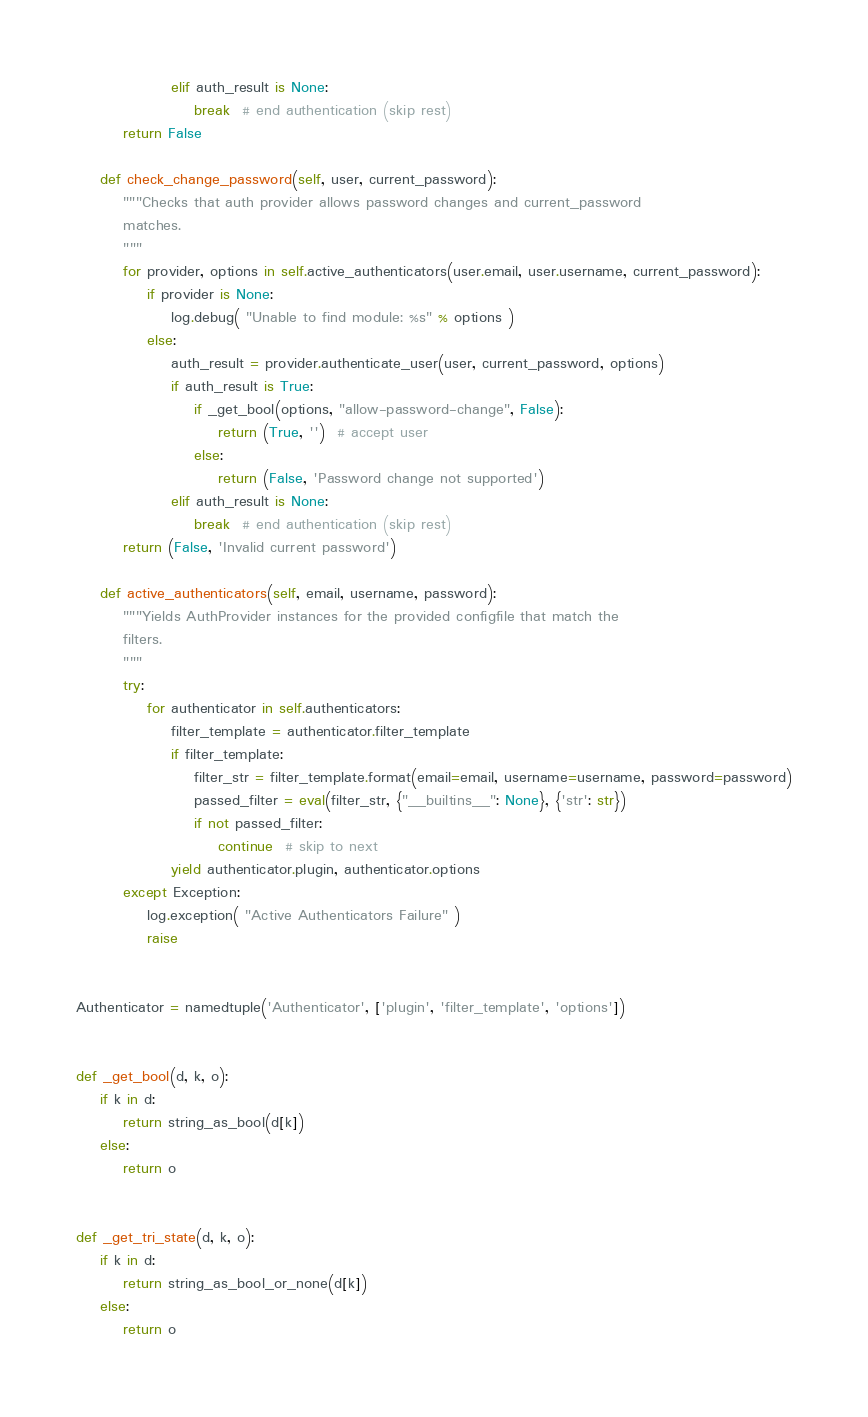Convert code to text. <code><loc_0><loc_0><loc_500><loc_500><_Python_>                elif auth_result is None:
                    break  # end authentication (skip rest)
        return False

    def check_change_password(self, user, current_password):
        """Checks that auth provider allows password changes and current_password
        matches.
        """
        for provider, options in self.active_authenticators(user.email, user.username, current_password):
            if provider is None:
                log.debug( "Unable to find module: %s" % options )
            else:
                auth_result = provider.authenticate_user(user, current_password, options)
                if auth_result is True:
                    if _get_bool(options, "allow-password-change", False):
                        return (True, '')  # accept user
                    else:
                        return (False, 'Password change not supported')
                elif auth_result is None:
                    break  # end authentication (skip rest)
        return (False, 'Invalid current password')

    def active_authenticators(self, email, username, password):
        """Yields AuthProvider instances for the provided configfile that match the
        filters.
        """
        try:
            for authenticator in self.authenticators:
                filter_template = authenticator.filter_template
                if filter_template:
                    filter_str = filter_template.format(email=email, username=username, password=password)
                    passed_filter = eval(filter_str, {"__builtins__": None}, {'str': str})
                    if not passed_filter:
                        continue  # skip to next
                yield authenticator.plugin, authenticator.options
        except Exception:
            log.exception( "Active Authenticators Failure" )
            raise


Authenticator = namedtuple('Authenticator', ['plugin', 'filter_template', 'options'])


def _get_bool(d, k, o):
    if k in d:
        return string_as_bool(d[k])
    else:
        return o


def _get_tri_state(d, k, o):
    if k in d:
        return string_as_bool_or_none(d[k])
    else:
        return o
</code> 